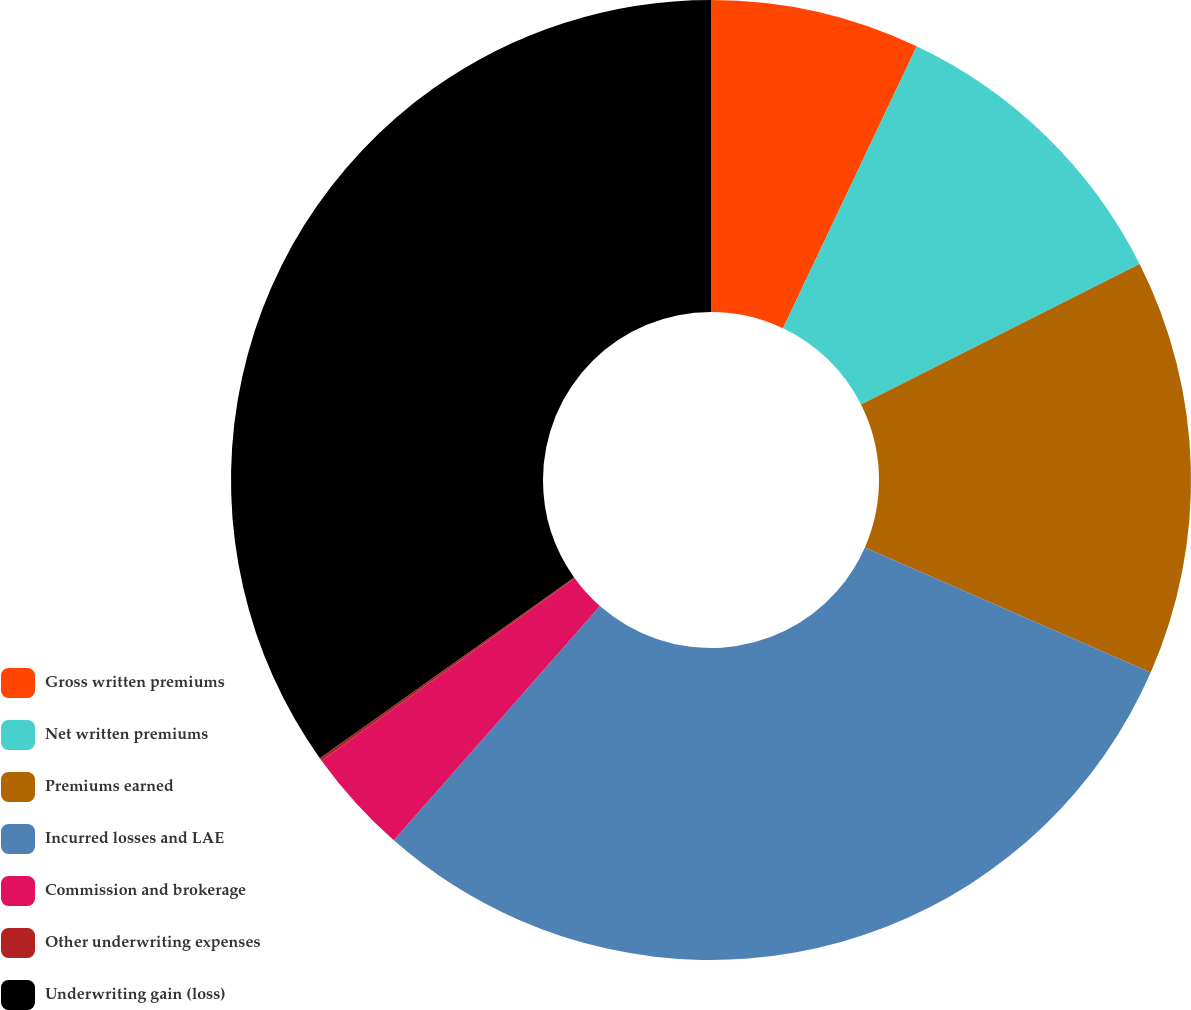Convert chart. <chart><loc_0><loc_0><loc_500><loc_500><pie_chart><fcel>Gross written premiums<fcel>Net written premiums<fcel>Premiums earned<fcel>Incurred losses and LAE<fcel>Commission and brokerage<fcel>Other underwriting expenses<fcel>Underwriting gain (loss)<nl><fcel>7.05%<fcel>10.52%<fcel>14.0%<fcel>29.92%<fcel>3.57%<fcel>0.1%<fcel>34.84%<nl></chart> 